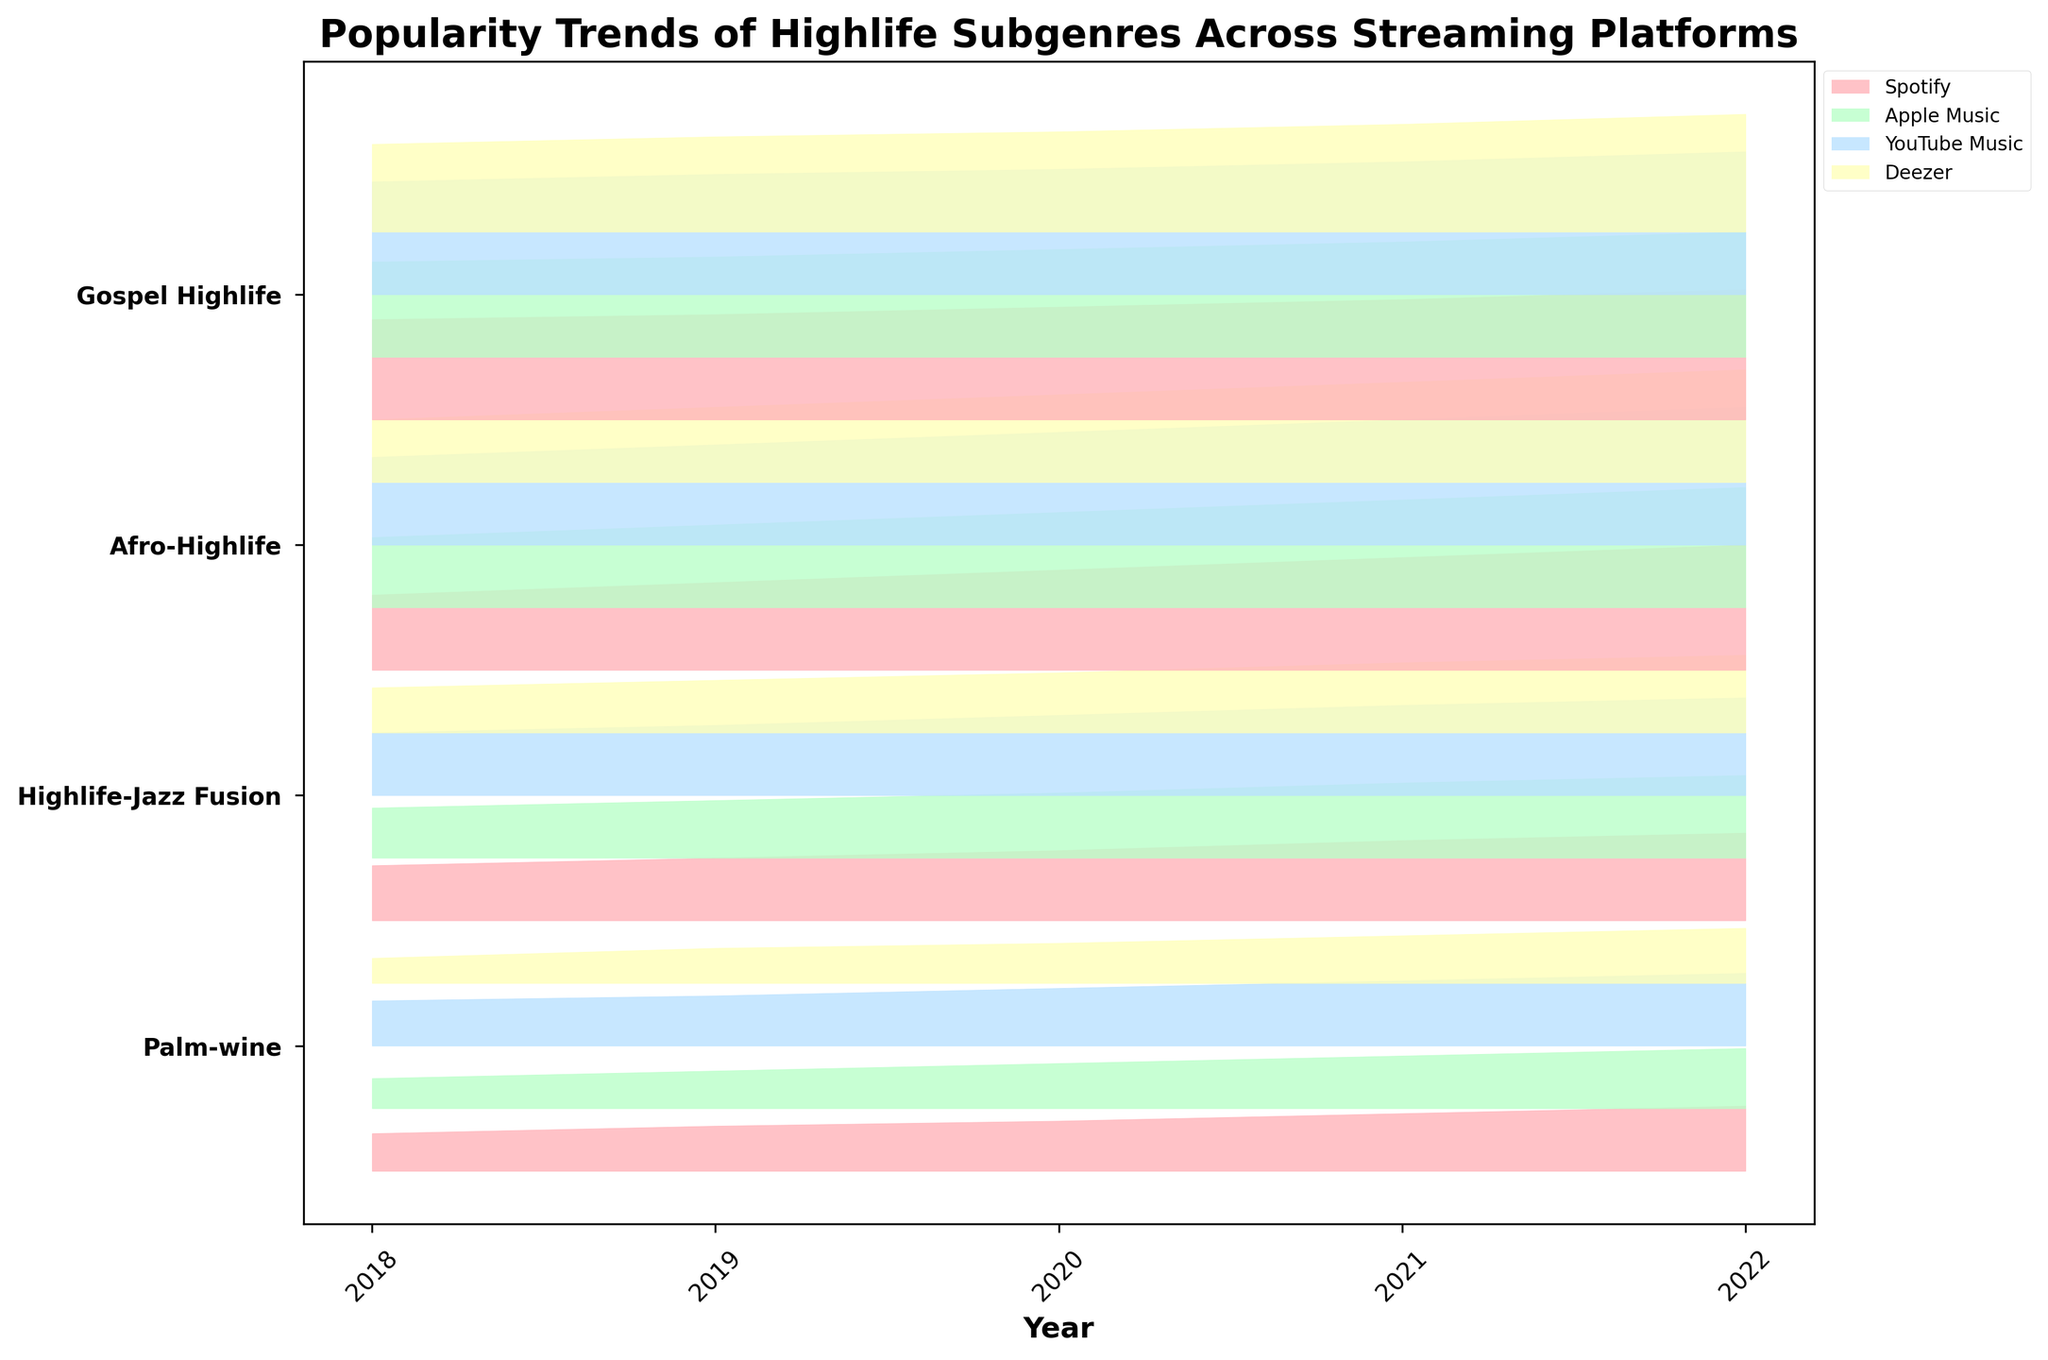How many streaming platforms are displayed in the figure? The figure legend lists the streaming platforms represented in the plot. Each platform is associated with a different color in the ridgeline plot. By counting these, we can see the total number of platforms displayed.
Answer: 4 What is the highest popularity score for Gospel Highlife in 2022 on YouTube Music? The highest point on the ridgeline corresponding to Gospel Highlife in 2022 for YouTube Music can be found by locating the highest peak for that subgenre-platform-year combination.
Answer: 57 How does the popularity of Afro-Highlife on Spotify in 2018 compare to its popularity in 2022? Locate Afro-Highlife scores on Spotify for 2018 and 2022. Compare these values to determine if the popularity has increased or decreased.
Answer: Increased Which year shows the highest overall popularity for the Highlife-Jazz Fusion subgenre across all platforms? Review the ridgeline peaks for Highlife-Jazz Fusion across years and platforms. The year with the highest aggregated peak value indicates the highest overall popularity.
Answer: 2022 What is the average popularity of Palm-wine subgenre across all platforms in 2020? Add the popularity scores of Palm-wine for all platforms in 2020 and divide by the number of platforms to get the average.
Answer: 19.25 Which subgenre experienced the greatest growth in popularity on Apple Music from 2018 to 2022? Compare the popularity scores of each subgenre on Apple Music in 2018 and 2022. Evaluate the differences to identify the greatest growth.
Answer: Afro-Highlife Is Spotify or Deezer more popular for Gospel Highlife in 2021? Compare the popularity scores of Gospel Highlife on Spotify and Deezer for 2021 by examining the corresponding ridgeline heights.
Answer: Spotify Which subgenre shows a consistent increase in popularity across all platforms from 2018 to 2022? Track the popularity trends for each subgenre year by year across all platforms. The subgenre with continuous growth shows consistent increase.
Answer: Gospel Highlife What trends do you observe for Palm-wine across different platforms from 2018 to 2022? Observe the ridgeline changes year by year for Palm-wine across platforms to identify any patterns or trends, such as increases, decreases, or stability.
Answer: Gradual Increase Which year had the lowest overall popularity for Afro-Highlife on Deezer? Examine the ridgeline plot for the lowest peak of Afro-Highlife on Deezer across the years.
Answer: 2018 